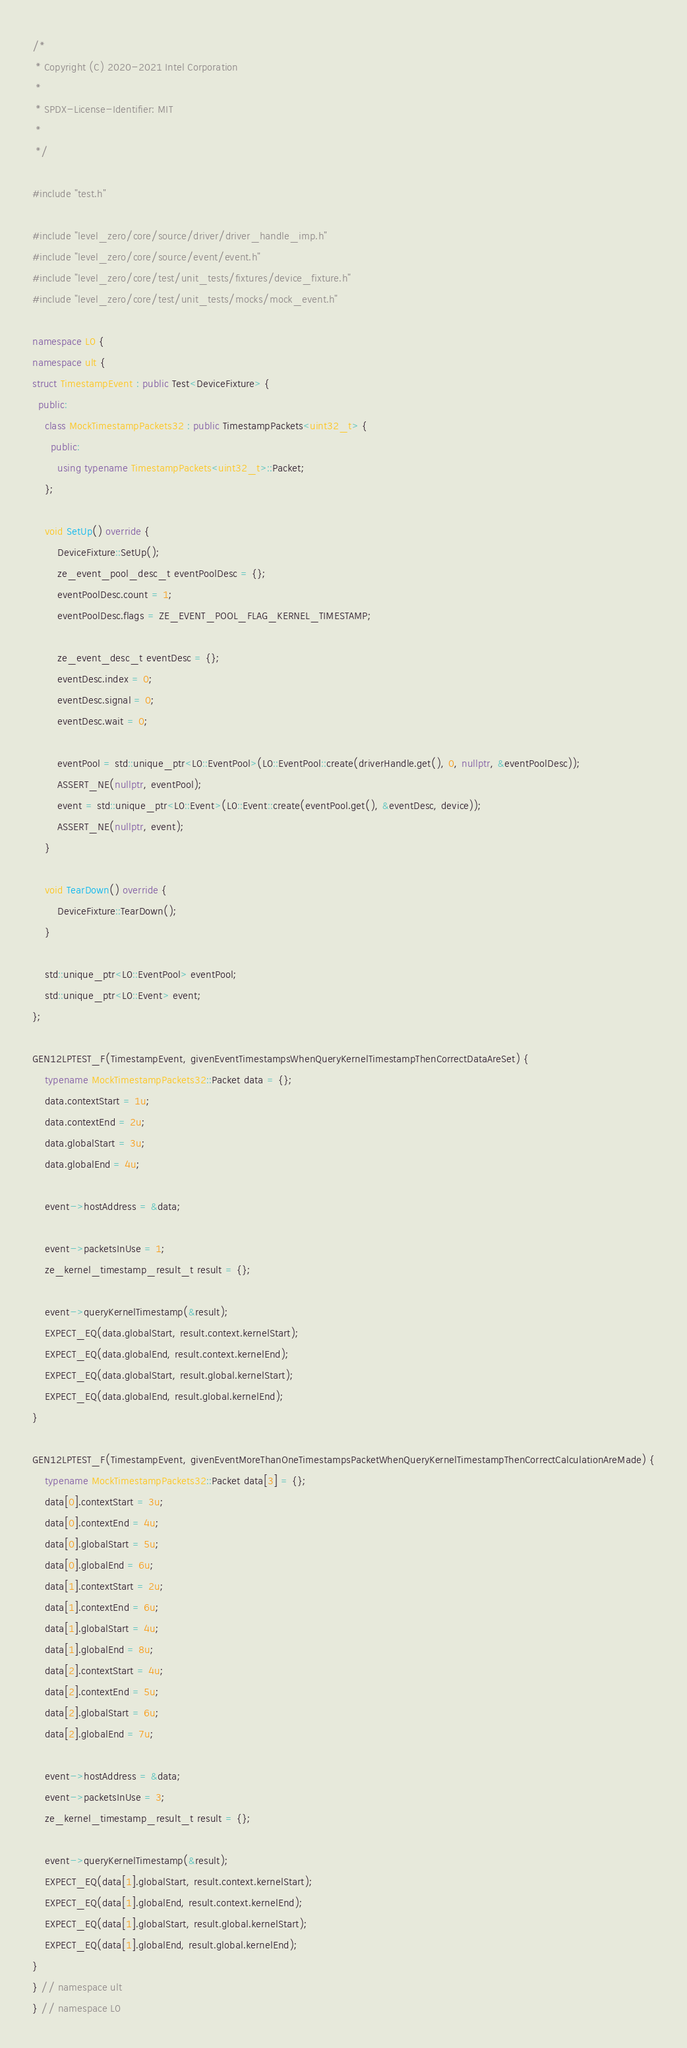Convert code to text. <code><loc_0><loc_0><loc_500><loc_500><_C++_>/*
 * Copyright (C) 2020-2021 Intel Corporation
 *
 * SPDX-License-Identifier: MIT
 *
 */

#include "test.h"

#include "level_zero/core/source/driver/driver_handle_imp.h"
#include "level_zero/core/source/event/event.h"
#include "level_zero/core/test/unit_tests/fixtures/device_fixture.h"
#include "level_zero/core/test/unit_tests/mocks/mock_event.h"

namespace L0 {
namespace ult {
struct TimestampEvent : public Test<DeviceFixture> {
  public:
    class MockTimestampPackets32 : public TimestampPackets<uint32_t> {
      public:
        using typename TimestampPackets<uint32_t>::Packet;
    };

    void SetUp() override {
        DeviceFixture::SetUp();
        ze_event_pool_desc_t eventPoolDesc = {};
        eventPoolDesc.count = 1;
        eventPoolDesc.flags = ZE_EVENT_POOL_FLAG_KERNEL_TIMESTAMP;

        ze_event_desc_t eventDesc = {};
        eventDesc.index = 0;
        eventDesc.signal = 0;
        eventDesc.wait = 0;

        eventPool = std::unique_ptr<L0::EventPool>(L0::EventPool::create(driverHandle.get(), 0, nullptr, &eventPoolDesc));
        ASSERT_NE(nullptr, eventPool);
        event = std::unique_ptr<L0::Event>(L0::Event::create(eventPool.get(), &eventDesc, device));
        ASSERT_NE(nullptr, event);
    }

    void TearDown() override {
        DeviceFixture::TearDown();
    }

    std::unique_ptr<L0::EventPool> eventPool;
    std::unique_ptr<L0::Event> event;
};

GEN12LPTEST_F(TimestampEvent, givenEventTimestampsWhenQueryKernelTimestampThenCorrectDataAreSet) {
    typename MockTimestampPackets32::Packet data = {};
    data.contextStart = 1u;
    data.contextEnd = 2u;
    data.globalStart = 3u;
    data.globalEnd = 4u;

    event->hostAddress = &data;

    event->packetsInUse = 1;
    ze_kernel_timestamp_result_t result = {};

    event->queryKernelTimestamp(&result);
    EXPECT_EQ(data.globalStart, result.context.kernelStart);
    EXPECT_EQ(data.globalEnd, result.context.kernelEnd);
    EXPECT_EQ(data.globalStart, result.global.kernelStart);
    EXPECT_EQ(data.globalEnd, result.global.kernelEnd);
}

GEN12LPTEST_F(TimestampEvent, givenEventMoreThanOneTimestampsPacketWhenQueryKernelTimestampThenCorrectCalculationAreMade) {
    typename MockTimestampPackets32::Packet data[3] = {};
    data[0].contextStart = 3u;
    data[0].contextEnd = 4u;
    data[0].globalStart = 5u;
    data[0].globalEnd = 6u;
    data[1].contextStart = 2u;
    data[1].contextEnd = 6u;
    data[1].globalStart = 4u;
    data[1].globalEnd = 8u;
    data[2].contextStart = 4u;
    data[2].contextEnd = 5u;
    data[2].globalStart = 6u;
    data[2].globalEnd = 7u;

    event->hostAddress = &data;
    event->packetsInUse = 3;
    ze_kernel_timestamp_result_t result = {};

    event->queryKernelTimestamp(&result);
    EXPECT_EQ(data[1].globalStart, result.context.kernelStart);
    EXPECT_EQ(data[1].globalEnd, result.context.kernelEnd);
    EXPECT_EQ(data[1].globalStart, result.global.kernelStart);
    EXPECT_EQ(data[1].globalEnd, result.global.kernelEnd);
}
} // namespace ult
} // namespace L0
</code> 